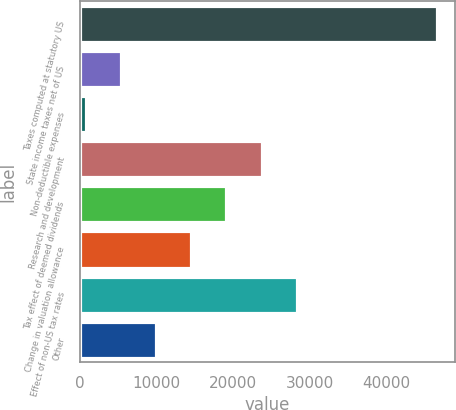Convert chart to OTSL. <chart><loc_0><loc_0><loc_500><loc_500><bar_chart><fcel>Taxes computed at statutory US<fcel>State income taxes net of US<fcel>Non-deductible expenses<fcel>Research and development<fcel>Tax effect of deemed dividends<fcel>Change in valuation allowance<fcel>Effect of non-US tax rates<fcel>Other<nl><fcel>46688<fcel>5368.1<fcel>777<fcel>23732.5<fcel>19141.4<fcel>14550.3<fcel>28323.6<fcel>9959.2<nl></chart> 